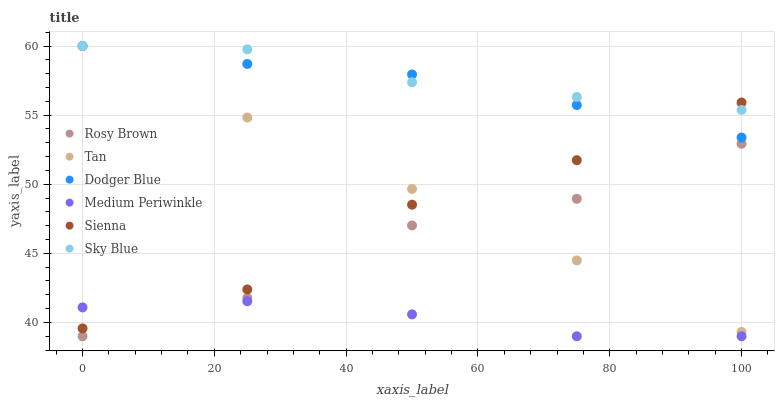Does Medium Periwinkle have the minimum area under the curve?
Answer yes or no. Yes. Does Sky Blue have the maximum area under the curve?
Answer yes or no. Yes. Does Sienna have the minimum area under the curve?
Answer yes or no. No. Does Sienna have the maximum area under the curve?
Answer yes or no. No. Is Tan the smoothest?
Answer yes or no. Yes. Is Rosy Brown the roughest?
Answer yes or no. Yes. Is Medium Periwinkle the smoothest?
Answer yes or no. No. Is Medium Periwinkle the roughest?
Answer yes or no. No. Does Rosy Brown have the lowest value?
Answer yes or no. Yes. Does Sienna have the lowest value?
Answer yes or no. No. Does Tan have the highest value?
Answer yes or no. Yes. Does Sienna have the highest value?
Answer yes or no. No. Is Rosy Brown less than Dodger Blue?
Answer yes or no. Yes. Is Dodger Blue greater than Medium Periwinkle?
Answer yes or no. Yes. Does Tan intersect Sienna?
Answer yes or no. Yes. Is Tan less than Sienna?
Answer yes or no. No. Is Tan greater than Sienna?
Answer yes or no. No. Does Rosy Brown intersect Dodger Blue?
Answer yes or no. No. 